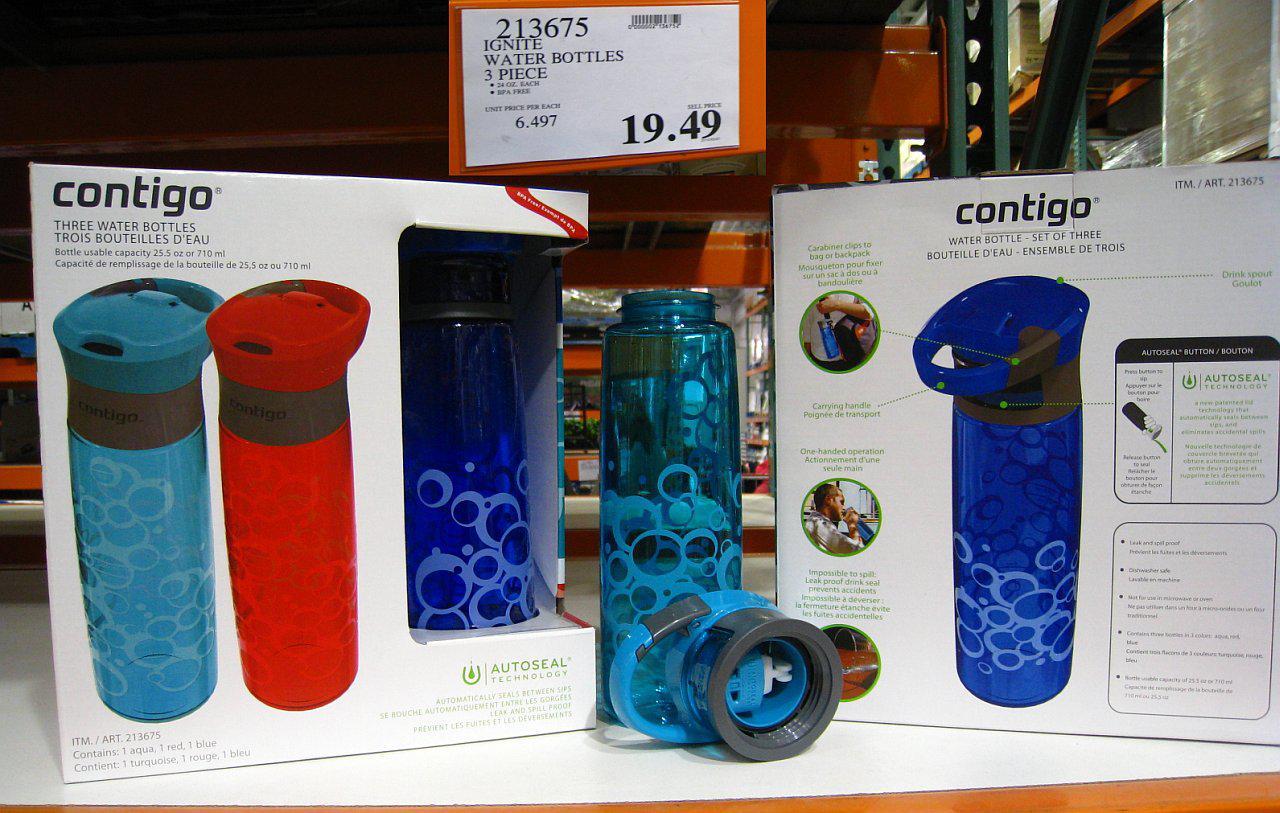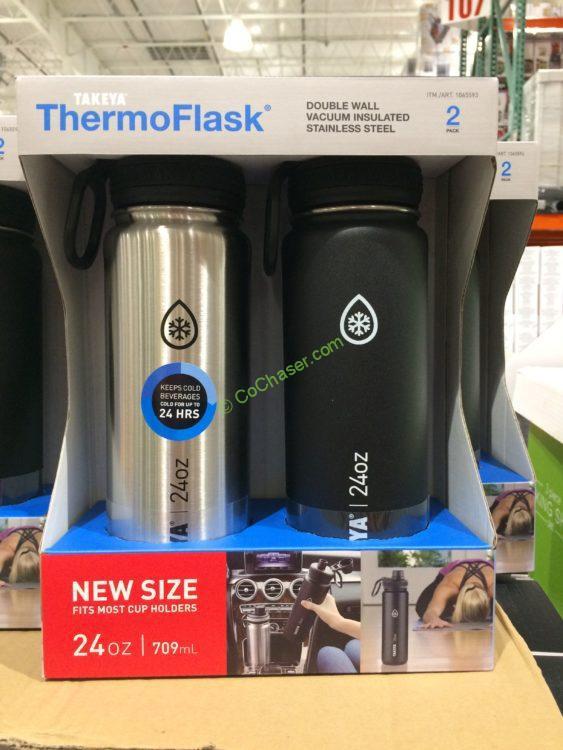The first image is the image on the left, the second image is the image on the right. Given the left and right images, does the statement "A package showing three different colors of water bottles features a trio of blue, violet and hot pink hexagon shapes on the bottom front of the box." hold true? Answer yes or no. No. The first image is the image on the left, the second image is the image on the right. Assess this claim about the two images: "A stainless steel water bottle is next to a green water bottle.". Correct or not? Answer yes or no. No. 